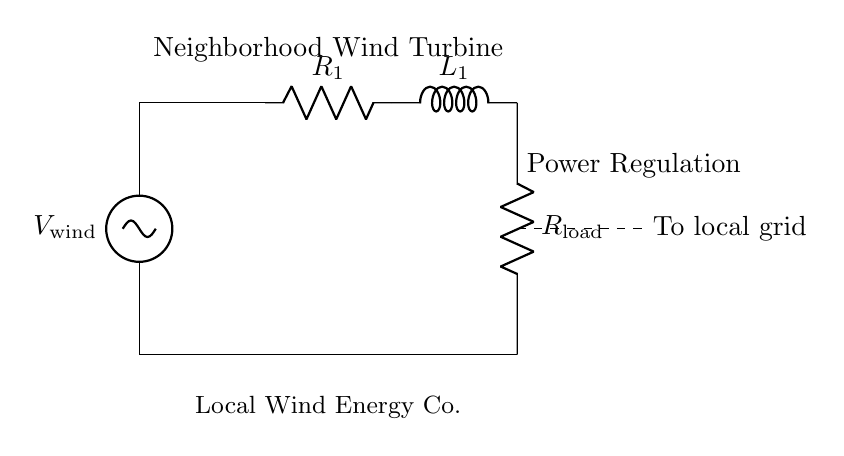What is the load resistor in this circuit? The load resistor is labeled as R_load, which is connected to the output side of the inductor L_1.
Answer: R_load What are the components used in this circuit? The components include a voltage source (V_wind), two resistors (R_1 and R_load), and one inductor (L_1).
Answer: V_wind, R_1, L_1, R_load What is the purpose of the inductor in this circuit? The inductor L_1 is used for filtering or smoothing the current flowing to the load resistor by storing energy in its magnetic field.
Answer: Filtering Is this circuit specifically designed for AC or DC? This circuit is typically designed for DC voltage regulation, as indicated by the presence of a steady voltage source (V_wind).
Answer: DC What happens if R_1 is increased? Increasing R_1 would lead to a decrease in the current flowing through the circuit, affecting the load power output.
Answer: Decreases current How is the wind turbine power regulated in this circuit? Power regulation occurs by adjusting the resistance (R_1) and using the inductor (L_1) to control the flow of current to the load, depending on wind speed variations.
Answer: Adjusting R_1 and L_1 